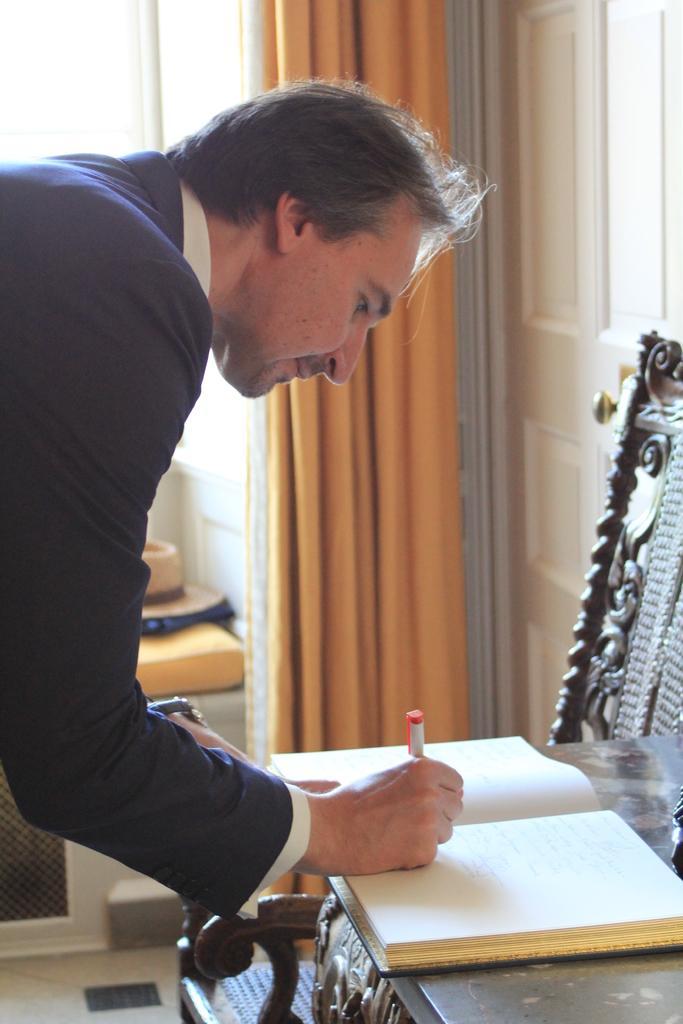Please provide a concise description of this image. In this image there is a man who is writing in the book. The book is on the table. In the background there is a curtain beside the door. Beside the table there is a chair. 